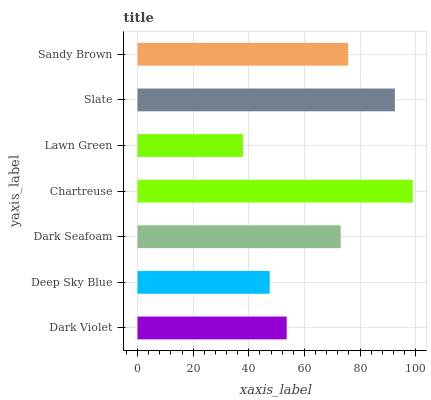Is Lawn Green the minimum?
Answer yes or no. Yes. Is Chartreuse the maximum?
Answer yes or no. Yes. Is Deep Sky Blue the minimum?
Answer yes or no. No. Is Deep Sky Blue the maximum?
Answer yes or no. No. Is Dark Violet greater than Deep Sky Blue?
Answer yes or no. Yes. Is Deep Sky Blue less than Dark Violet?
Answer yes or no. Yes. Is Deep Sky Blue greater than Dark Violet?
Answer yes or no. No. Is Dark Violet less than Deep Sky Blue?
Answer yes or no. No. Is Dark Seafoam the high median?
Answer yes or no. Yes. Is Dark Seafoam the low median?
Answer yes or no. Yes. Is Deep Sky Blue the high median?
Answer yes or no. No. Is Deep Sky Blue the low median?
Answer yes or no. No. 